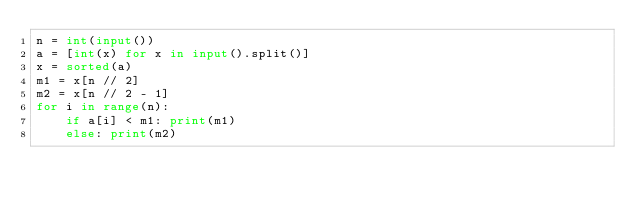<code> <loc_0><loc_0><loc_500><loc_500><_Python_>n = int(input())
a = [int(x) for x in input().split()]
x = sorted(a)
m1 = x[n // 2]
m2 = x[n // 2 - 1]
for i in range(n):
    if a[i] < m1: print(m1)
    else: print(m2)
</code> 